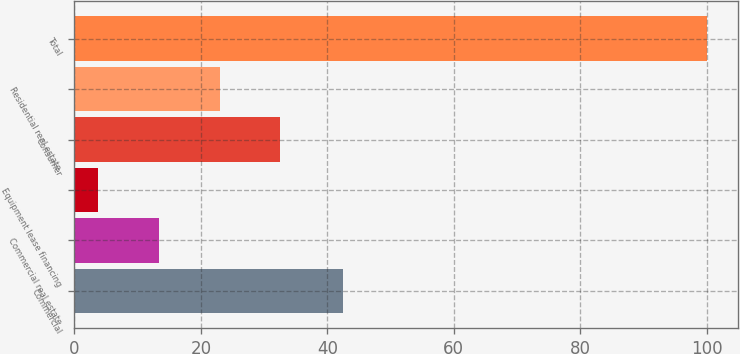Convert chart. <chart><loc_0><loc_0><loc_500><loc_500><bar_chart><fcel>Commercial<fcel>Commercial real estate<fcel>Equipment lease financing<fcel>Consumer<fcel>Residential real estate<fcel>Total<nl><fcel>42.4<fcel>13.33<fcel>3.7<fcel>32.59<fcel>22.96<fcel>100<nl></chart> 